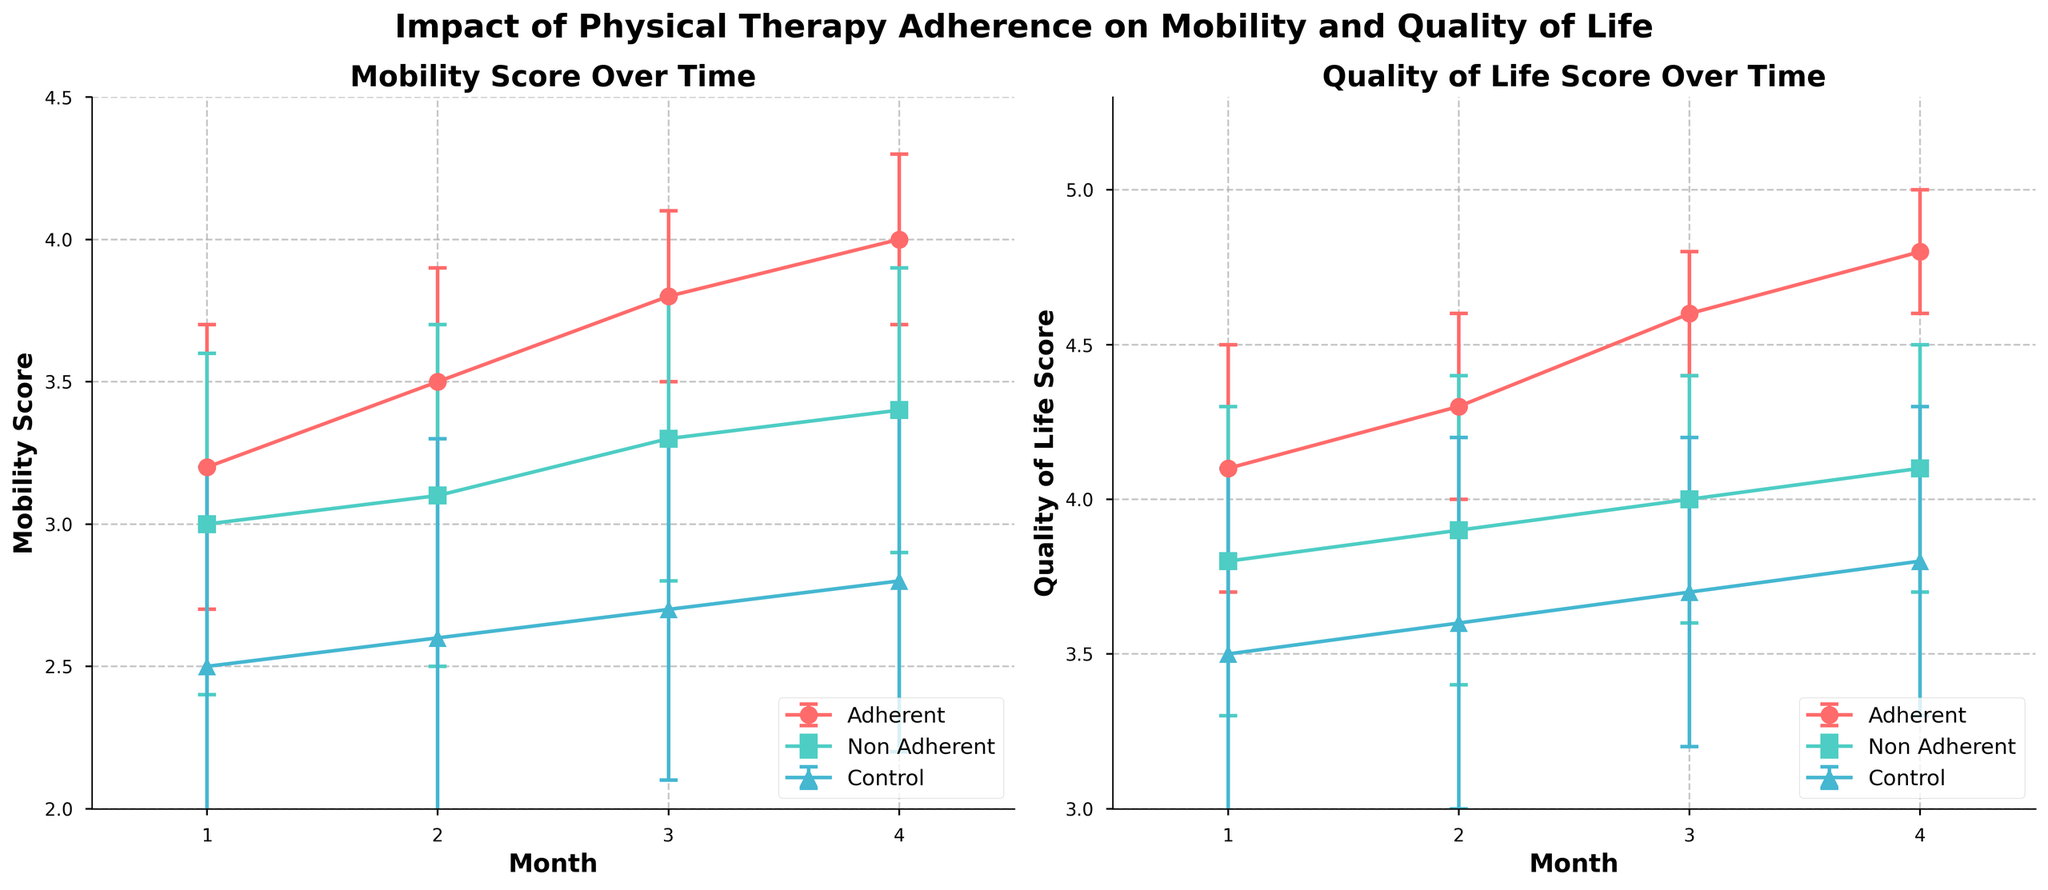What is the title of the figure? The title is usually located at the top of the figure and provides a summary of what the figure represents. Here, it is located at the top center.
Answer: Impact of Physical Therapy Adherence on Mobility and Quality of Life How many patient groups are shown in the figure? You can identify the number of patient groups by looking at the legend, which describes the different colored lines and markers.
Answer: 3 Which patient group has the highest mean mobility score at month 4? Look at the mobility scores at month 4 on the left plot and compare the different lines. The group with the highest point is the one you are looking for.
Answer: Adherent How do the mean quality of life scores of the Adherent group compare between month 1 and month 4? Find the quality of life scores for the Adherent group on the right plot at month 1 and month 4 and calculate the difference.
Answer: Increased from 4.1 to 4.8 What is the general trend of the mobility scores for the Non-Adherent group over the 4 months? Observe the line corresponding to the Non-Adherent group on the left plot and describe its overall direction from month 1 to month 4.
Answer: Increasing Which group has the smallest error bars for mobility score at month 4? Examine the error bars at month 4 on the left plot and find the shortest one, indicating the least variability.
Answer: Adherent At month 2, how much higher is the mean quality of life score of the Adherent group compared to the Control group? Subtract the mean quality of life score of the Control group from the Adherent group at month 2 on the right plot.
Answer: 0.7 higher How do the mobility scores for the Control group change from month 1 to month 4? Follow the line representing the Control group on the left plot from month 1 to month 4 and note the change.
Answer: Increase from 2.5 to 2.8 Between which two months does the Adherent group show the largest increase in mean mobility score? Compare the differences in mean mobility scores for the Adherent group between each consecutive month on the left plot and find the largest one.
Answer: Month 1 to Month 2 